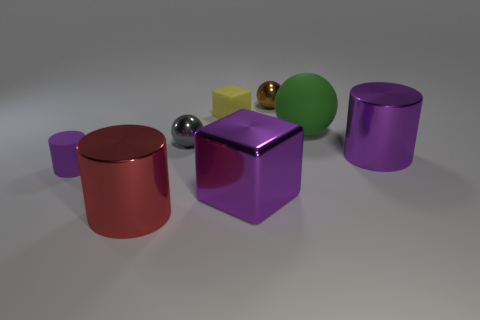What number of things are either large red objects or things in front of the green rubber object?
Make the answer very short. 5. The small shiny object on the left side of the small metallic object that is right of the gray object is what color?
Your response must be concise. Gray. There is a large shiny cylinder right of the yellow rubber cube; is it the same color as the rubber cylinder?
Offer a terse response. Yes. What is the material of the block that is behind the large matte sphere?
Your answer should be compact. Rubber. What is the size of the red metallic thing?
Offer a very short reply. Large. Is the material of the tiny block that is to the right of the red thing the same as the large green sphere?
Make the answer very short. Yes. What number of large red metallic spheres are there?
Your answer should be compact. 0. What number of objects are either green things or metal cylinders?
Provide a short and direct response. 3. What number of small yellow rubber objects are to the left of the large cylinder that is right of the tiny shiny ball left of the tiny brown metal object?
Make the answer very short. 1. Are there any other things of the same color as the small rubber cylinder?
Offer a terse response. Yes. 